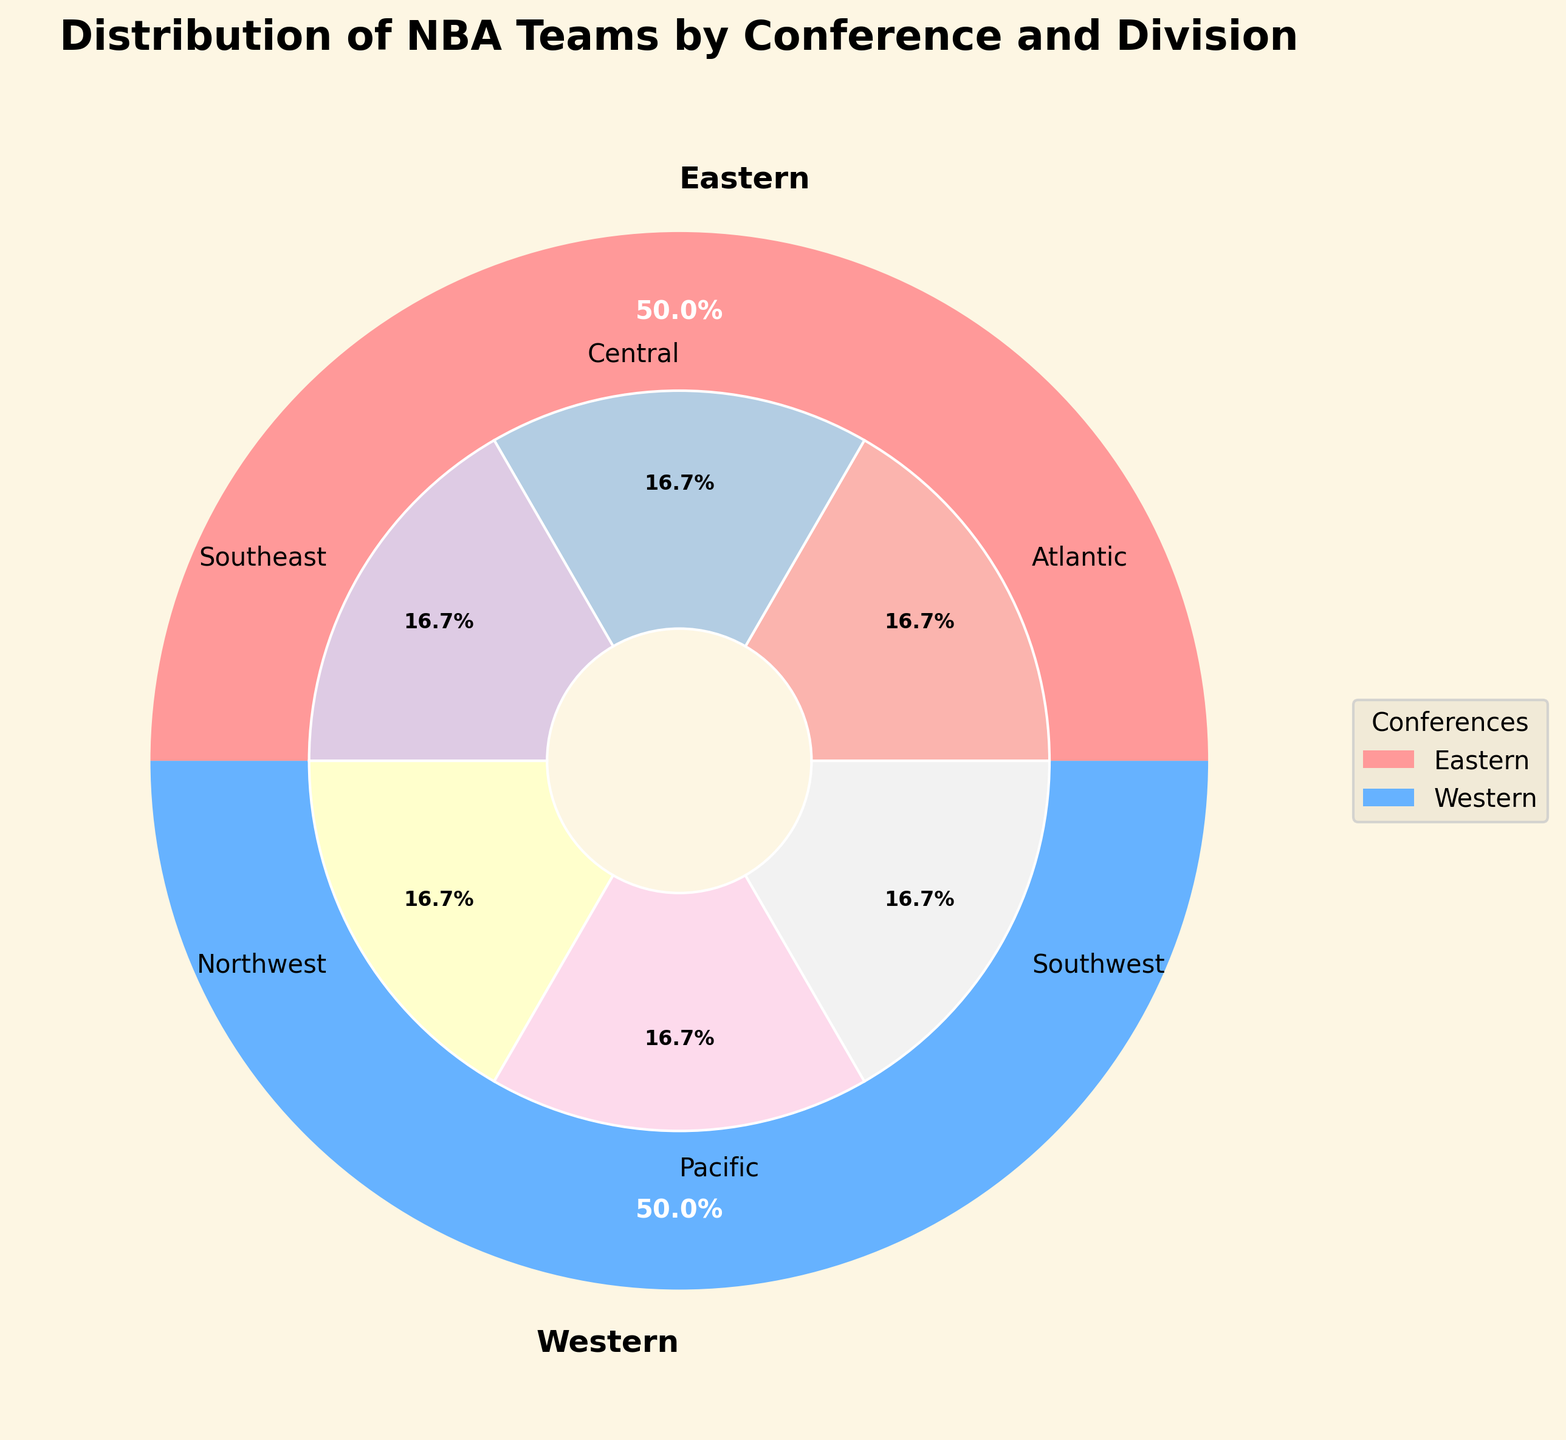what percentage of NBA teams are in the Eastern Conference? To find this, we look at the outer pie chart and see the segment labeled "Eastern," which shows the percentage value.
Answer: 50% How many divisions are there in each conference? By counting the segments in the inner pie chart for each outer section, we see that each conference is divided into three divisions.
Answer: 3 Which division has the highest number of teams in the Eastern Conference? According to the inner pie chart, all divisions in the Eastern Conference have equal shares as each division has 5 teams.
Answer: All divisions Is the number of teams in the Western Conference greater than the number of teams in the Eastern Conference? Both the Eastern and Western Conferences are shown to have equal percentages (50%) in the outer pie chart, indicating they have the same number of teams.
Answer: No What is the percentage contribution of each division in the Western Conference to the overall number of NBA teams? Each division in the Western Conference has 5 teams, so their combined percentage of the total teams is: (5/30) * 100 = 16.67%.
Answer: 16.67% If one more team is added to the Pacific Division while the total number of teams remains the same, what will be the new percentage of teams in the Pacific Division in the Western Conference? Adding one team to the Pacific Division, changing its number of teams from 5 to 6, while keeping the total number of teams in the Western Conference at 15 means its new percentage is (6/15) * 100.
Answer: 40% How does the visual representation help in understanding the distribution of NBA teams across conferences and divisions? The concentric pies allow easy visualization of the distribution, with the outer pie showing the broad split between conferences and the inner pie detailing the divisions within each conference.
Answer: Clear distribution across categories Which conference has more divisions with identical team counts? Both the Eastern and Western Conferences have equal divisions with identical team counts as all divisions have 5 teams each.
Answer: Both conferences What visual cue indicates the difference between the inner and outer sections of the pie chart? The visual distinction is made by using different radii and widths for the outer pie (wider) and the inner pie (narrower) sections, along with colors to differentiate components.
Answer: Radii and colors 